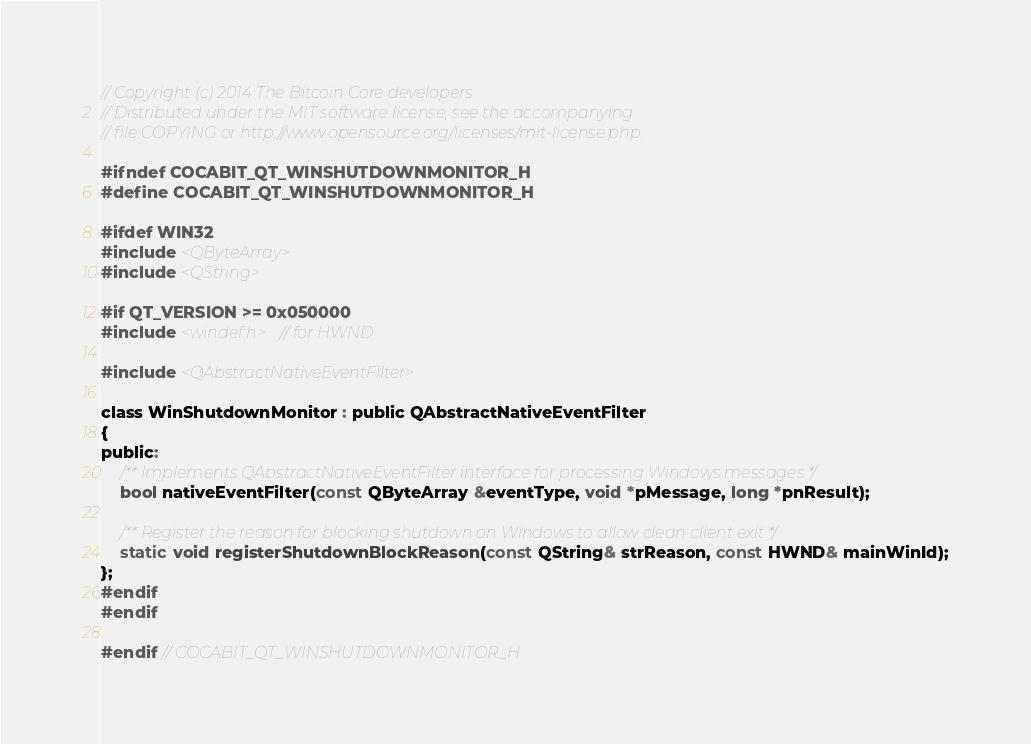<code> <loc_0><loc_0><loc_500><loc_500><_C_>// Copyright (c) 2014 The Bitcoin Core developers
// Distributed under the MIT software license, see the accompanying
// file COPYING or http://www.opensource.org/licenses/mit-license.php.

#ifndef COCABIT_QT_WINSHUTDOWNMONITOR_H
#define COCABIT_QT_WINSHUTDOWNMONITOR_H

#ifdef WIN32
#include <QByteArray>
#include <QString>

#if QT_VERSION >= 0x050000
#include <windef.h> // for HWND

#include <QAbstractNativeEventFilter>

class WinShutdownMonitor : public QAbstractNativeEventFilter
{
public:
    /** Implements QAbstractNativeEventFilter interface for processing Windows messages */
    bool nativeEventFilter(const QByteArray &eventType, void *pMessage, long *pnResult);

    /** Register the reason for blocking shutdown on Windows to allow clean client exit */
    static void registerShutdownBlockReason(const QString& strReason, const HWND& mainWinId);
};
#endif
#endif

#endif // COCABIT_QT_WINSHUTDOWNMONITOR_H
</code> 